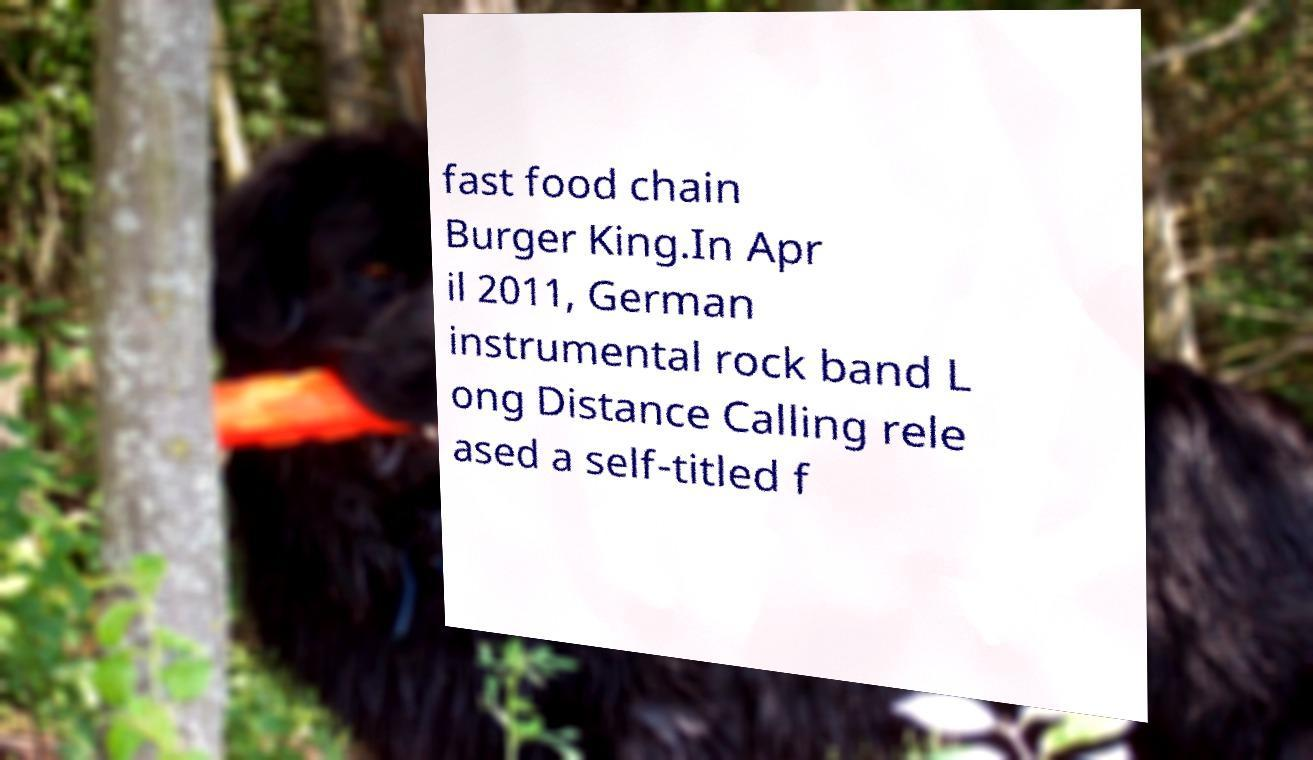I need the written content from this picture converted into text. Can you do that? fast food chain Burger King.In Apr il 2011, German instrumental rock band L ong Distance Calling rele ased a self-titled f 